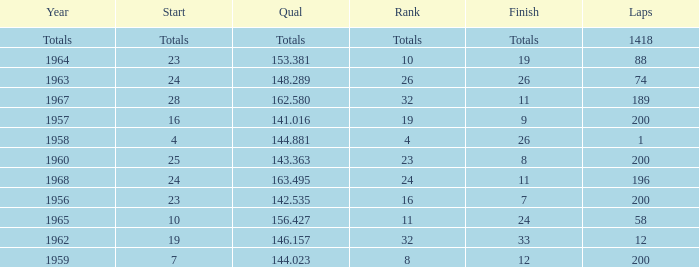What is the highest number of laps that also has a finish total of 8? 200.0. 